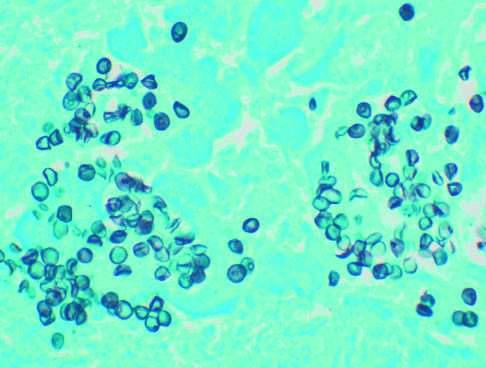does silver stain demonstrate cup-shaped and round cysts within the exudate?
Answer the question using a single word or phrase. Yes 